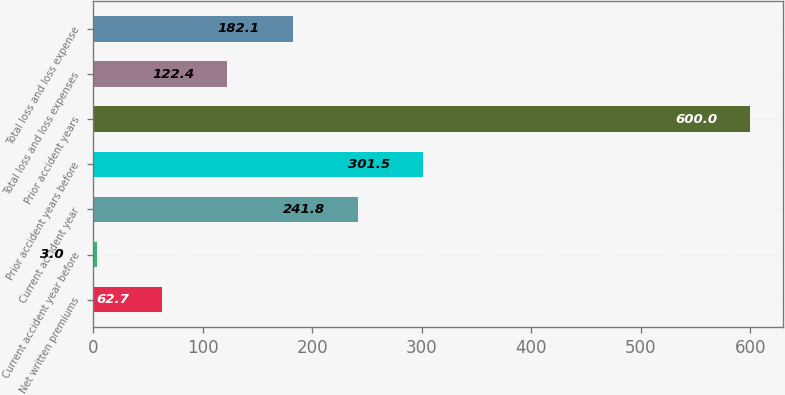Convert chart. <chart><loc_0><loc_0><loc_500><loc_500><bar_chart><fcel>Net written premiums<fcel>Current accident year before<fcel>Current accident year<fcel>Prior accident years before<fcel>Prior accident years<fcel>Total loss and loss expenses<fcel>Total loss and loss expense<nl><fcel>62.7<fcel>3<fcel>241.8<fcel>301.5<fcel>600<fcel>122.4<fcel>182.1<nl></chart> 